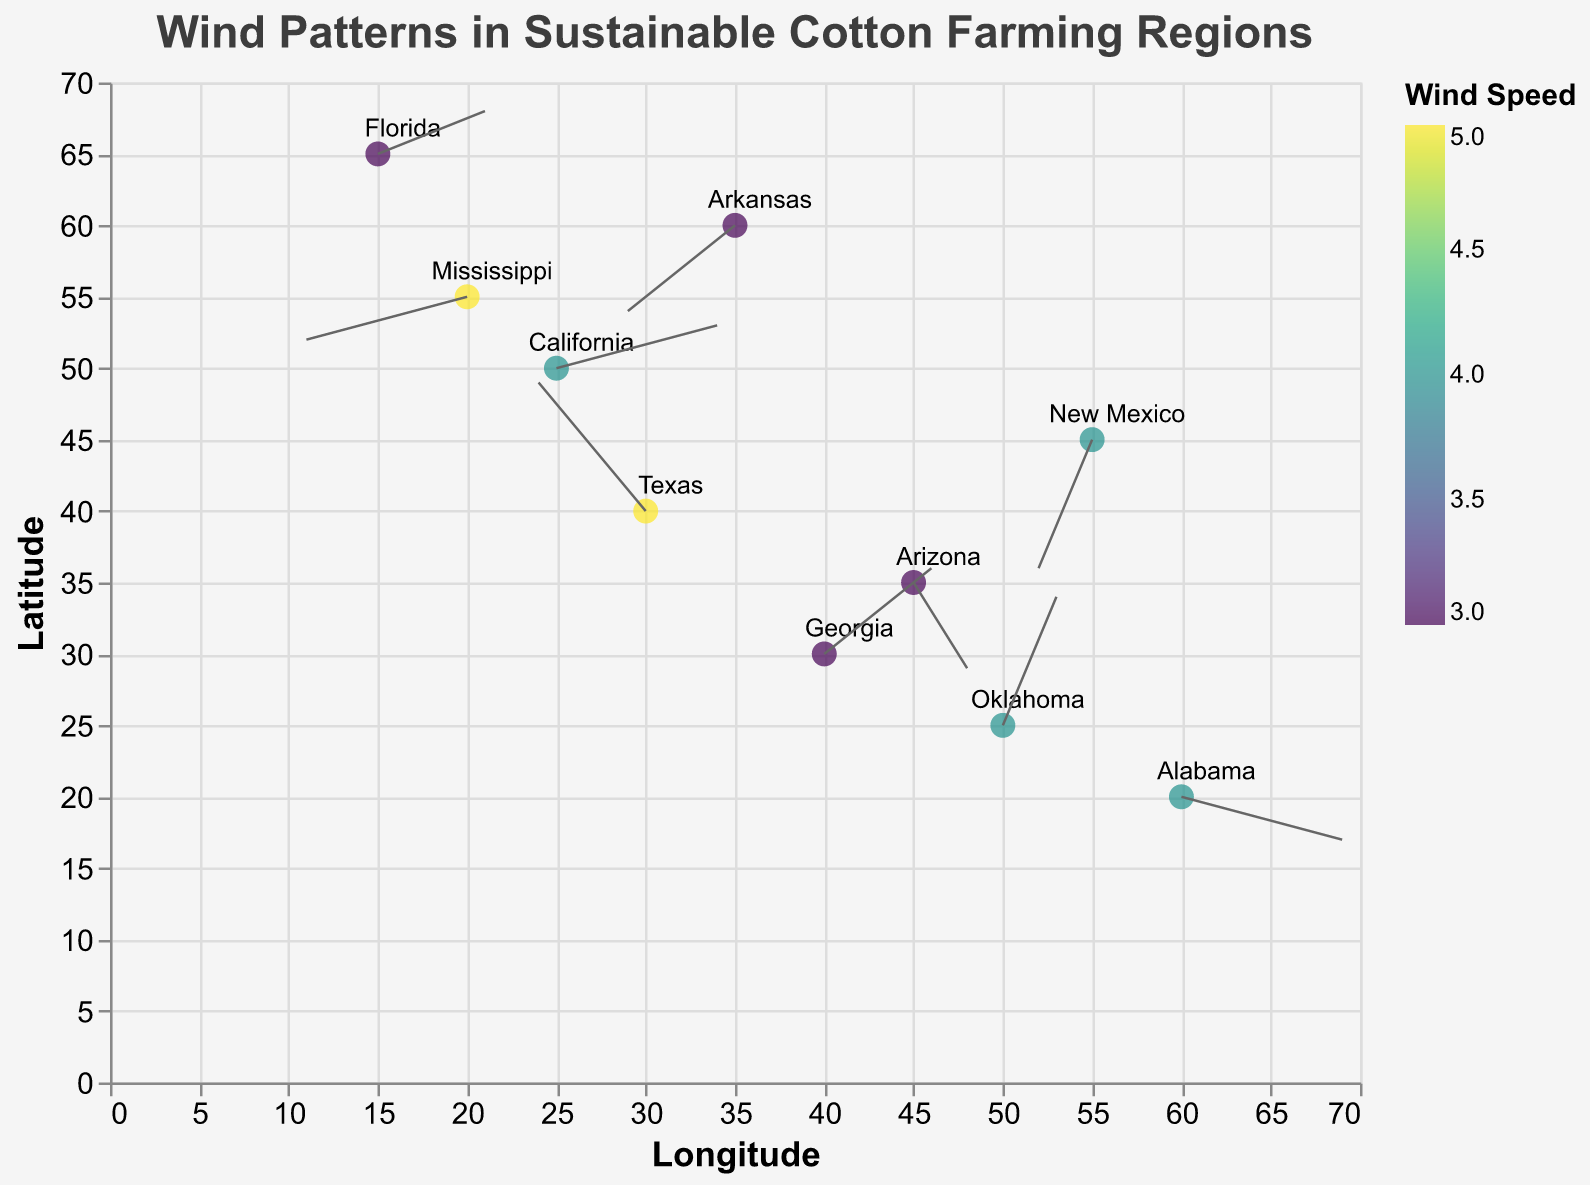What's the title of the figure? The title is found at the top of the figure and describes the overall content it represents. Here, the title text states: "Wind Patterns in Sustainable Cotton Farming Regions."
Answer: Wind Patterns in Sustainable Cotton Farming Regions How many regions are represented on the plot? By counting the labels on the plot, each representing a unique region, we can determine the number of regions. The regions listed are Texas, Arizona, California, New Mexico, Georgia, Mississippi, Oklahoma, Arkansas, Alabama, and Florida.
Answer: 10 Which region experiences the highest wind speed? Wind speed is indicated by color according to the legend. By matching the color gradient with the legend, we can identify that both Texas and Mississippi have the wind speed corresponding to the highest color value. The tooltip further confirms this.
Answer: Texas and Mississippi What is the average wind speed across all regions? Total wind speeds are summed, and then divided by the number of regions. The wind speeds are 5, 3, 4, 4, 3, 5, 4, 3, 4, and 3. Adding them gives 38, and 38 divided by 10 regions is 3.8.
Answer: 3.8 Which region has the most northeasterly wind direction? Northeasterly winds have negative U (west to east) and positive V (south to north) vectors. From the data, Texas with U = -2 and V = 3 matches this.
Answer: Texas In which region does the wind pattern suggest an eastward direction with a northward component? An eastward direction with a northward component means positive U (west to east) and positive V (south to north). From the data, Oklahoma with U = 1 and V = 3 matches this direction.
Answer: Oklahoma Which two regions have the exact same wind speed? By examining the wind speeds shown by different colors and confirmed with the legend, we find that California, New Mexico, Oklahoma, and Alabama all have the same wind speed of 4.
Answer: California, New Mexico, Oklahoma, and Alabama What's the distance covered by the wind vector in New Mexico based on its U and V components? The distance is found using the Pythagorean theorem \(\sqrt{U^2 + V^2}\). For New Mexico, \(U = -1\) and \(V = -3\). Distance is \(\sqrt{(-1)^2 + (-3)^2} = \sqrt{1 + 9} = \sqrt{10} \approx 3.16\).
Answer: 3.16 Which region has the southernmost location on the y-axis? The southernmost location corresponds to the lowest Y value. From the data, Alabama has Y = 20, the lowest value on the latitude axis.
Answer: Alabama 